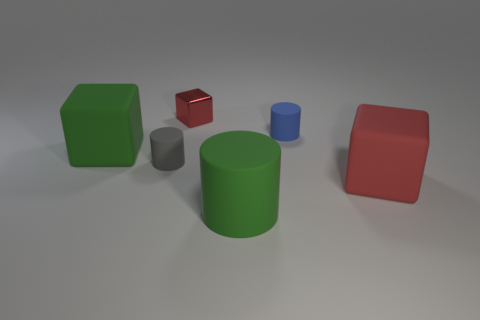Subtract all tiny cylinders. How many cylinders are left? 1 Subtract all red blocks. How many blocks are left? 1 Subtract 1 cylinders. How many cylinders are left? 2 Subtract all gray spheres. How many gray blocks are left? 0 Add 3 small red things. How many small red things exist? 4 Add 4 big purple blocks. How many objects exist? 10 Subtract 0 gray cubes. How many objects are left? 6 Subtract all yellow cylinders. Subtract all purple balls. How many cylinders are left? 3 Subtract all big purple metal balls. Subtract all red metallic blocks. How many objects are left? 5 Add 1 small red shiny blocks. How many small red shiny blocks are left? 2 